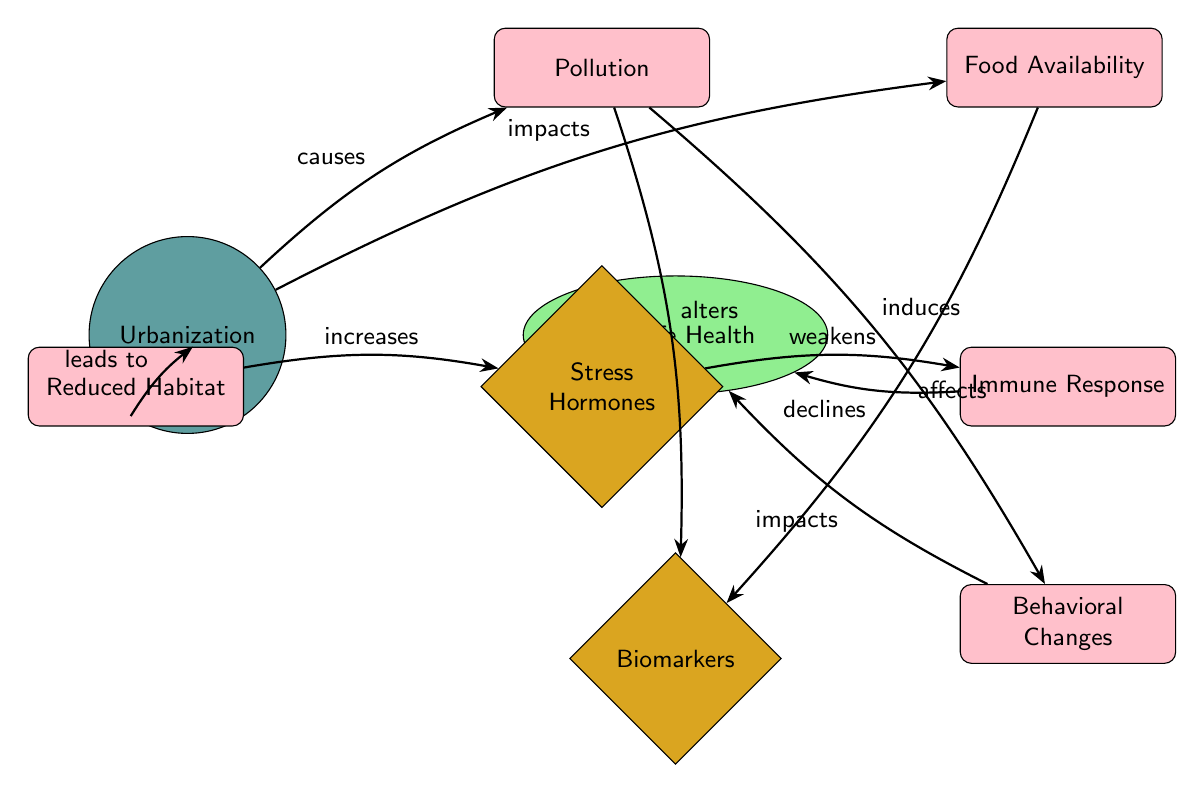What are the two main outcomes affected by urbanization? The diagram shows two main outcomes impacted by urbanization, which are pollution and reduced habitat. Both outcomes are directly linked to the central theme of urbanization as represented by the arrows leading from it.
Answer: Pollution, Reduced Habitat How many biomarkers are listed in this diagram? The diagram lists three biomarkers: stress hormones, immune response, and behavioral changes. Each of these is represented as a distinct diamond-shaped node below the wildlife health node.
Answer: Three What does pollution alter? Pollution is shown to alter biomarkers according to the relationship indicated by the arrow that connects pollution to the biomarkers node in the diagram.
Answer: Biomarkers Which factor leads to reduced habitat? The arrow connected to the reduced habitat node shows that urbanization leads to reduced habitat, which is represented in the diagram through the "leads to" label on the connecting edge.
Answer: Urbanization How does stress hormones impact wildlife health? The diagram specifies that stress hormones weaken the immune response, which ultimately declines wildlife health. This sequence of relationships demonstrates how each factor impacts the overall outcome for wildlife health.
Answer: Weakens What are the effects of food availability on biomarkers? Food availability affects biomarkers, as indicated by the edge connecting the food availability node to the biomarkers node, which shows a direct relationship.
Answer: Affects What causes behavioral changes? The diagram illustrates that pollution induces behavioral changes, with an arrow pointing from pollution to behavioral changes, clearly marking this causal relationship.
Answer: Pollution Which factor is connected to both wildlife health and biomarkers? The stress hormones node connects to both wildlife health and biomarkers, as indicated by the edges leading from stress hormones to these two nodes in the diagram, highlighting its significant role.
Answer: Stress Hormones 